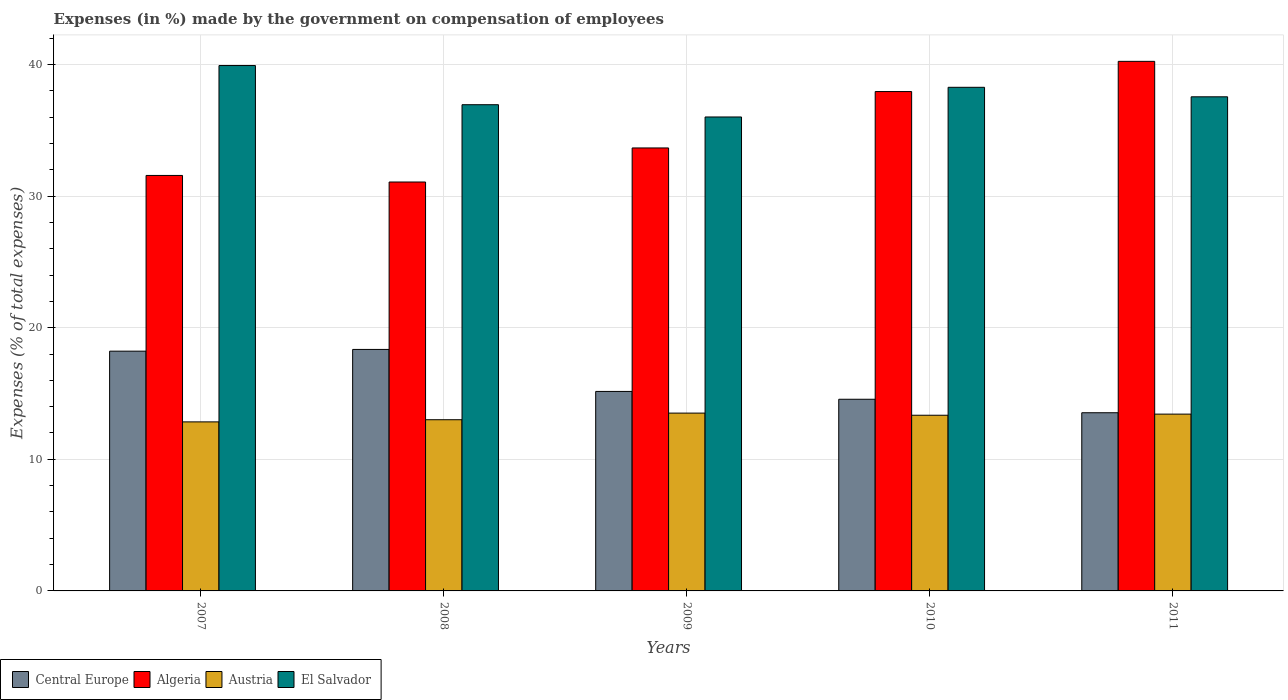How many different coloured bars are there?
Offer a very short reply. 4. How many groups of bars are there?
Provide a short and direct response. 5. Are the number of bars per tick equal to the number of legend labels?
Offer a terse response. Yes. Are the number of bars on each tick of the X-axis equal?
Your answer should be very brief. Yes. How many bars are there on the 1st tick from the left?
Make the answer very short. 4. How many bars are there on the 3rd tick from the right?
Offer a very short reply. 4. What is the label of the 4th group of bars from the left?
Provide a succinct answer. 2010. In how many cases, is the number of bars for a given year not equal to the number of legend labels?
Provide a short and direct response. 0. What is the percentage of expenses made by the government on compensation of employees in Central Europe in 2011?
Make the answer very short. 13.54. Across all years, what is the maximum percentage of expenses made by the government on compensation of employees in Algeria?
Make the answer very short. 40.23. Across all years, what is the minimum percentage of expenses made by the government on compensation of employees in El Salvador?
Keep it short and to the point. 36.01. What is the total percentage of expenses made by the government on compensation of employees in Austria in the graph?
Provide a succinct answer. 66.14. What is the difference between the percentage of expenses made by the government on compensation of employees in Algeria in 2007 and that in 2008?
Keep it short and to the point. 0.5. What is the difference between the percentage of expenses made by the government on compensation of employees in Algeria in 2008 and the percentage of expenses made by the government on compensation of employees in Austria in 2009?
Keep it short and to the point. 17.56. What is the average percentage of expenses made by the government on compensation of employees in Austria per year?
Offer a terse response. 13.23. In the year 2010, what is the difference between the percentage of expenses made by the government on compensation of employees in Austria and percentage of expenses made by the government on compensation of employees in El Salvador?
Make the answer very short. -24.92. In how many years, is the percentage of expenses made by the government on compensation of employees in Central Europe greater than 16 %?
Offer a very short reply. 2. What is the ratio of the percentage of expenses made by the government on compensation of employees in Central Europe in 2008 to that in 2009?
Provide a short and direct response. 1.21. Is the percentage of expenses made by the government on compensation of employees in Austria in 2007 less than that in 2009?
Offer a very short reply. Yes. What is the difference between the highest and the second highest percentage of expenses made by the government on compensation of employees in Central Europe?
Ensure brevity in your answer.  0.13. What is the difference between the highest and the lowest percentage of expenses made by the government on compensation of employees in Algeria?
Offer a very short reply. 9.17. In how many years, is the percentage of expenses made by the government on compensation of employees in El Salvador greater than the average percentage of expenses made by the government on compensation of employees in El Salvador taken over all years?
Offer a very short reply. 2. Is the sum of the percentage of expenses made by the government on compensation of employees in El Salvador in 2009 and 2010 greater than the maximum percentage of expenses made by the government on compensation of employees in Algeria across all years?
Give a very brief answer. Yes. Is it the case that in every year, the sum of the percentage of expenses made by the government on compensation of employees in Central Europe and percentage of expenses made by the government on compensation of employees in Austria is greater than the sum of percentage of expenses made by the government on compensation of employees in Algeria and percentage of expenses made by the government on compensation of employees in El Salvador?
Give a very brief answer. No. What does the 2nd bar from the left in 2008 represents?
Your answer should be compact. Algeria. What does the 4th bar from the right in 2011 represents?
Offer a terse response. Central Europe. How many bars are there?
Provide a short and direct response. 20. Are the values on the major ticks of Y-axis written in scientific E-notation?
Make the answer very short. No. Does the graph contain any zero values?
Your answer should be very brief. No. Where does the legend appear in the graph?
Provide a short and direct response. Bottom left. What is the title of the graph?
Your answer should be compact. Expenses (in %) made by the government on compensation of employees. Does "Bahrain" appear as one of the legend labels in the graph?
Your answer should be very brief. No. What is the label or title of the X-axis?
Provide a short and direct response. Years. What is the label or title of the Y-axis?
Your answer should be very brief. Expenses (% of total expenses). What is the Expenses (% of total expenses) in Central Europe in 2007?
Your response must be concise. 18.22. What is the Expenses (% of total expenses) in Algeria in 2007?
Your answer should be very brief. 31.57. What is the Expenses (% of total expenses) of Austria in 2007?
Offer a terse response. 12.84. What is the Expenses (% of total expenses) of El Salvador in 2007?
Give a very brief answer. 39.92. What is the Expenses (% of total expenses) in Central Europe in 2008?
Provide a succinct answer. 18.35. What is the Expenses (% of total expenses) of Algeria in 2008?
Your answer should be compact. 31.07. What is the Expenses (% of total expenses) of Austria in 2008?
Offer a terse response. 13.01. What is the Expenses (% of total expenses) of El Salvador in 2008?
Make the answer very short. 36.94. What is the Expenses (% of total expenses) in Central Europe in 2009?
Provide a short and direct response. 15.16. What is the Expenses (% of total expenses) of Algeria in 2009?
Offer a very short reply. 33.66. What is the Expenses (% of total expenses) in Austria in 2009?
Your response must be concise. 13.51. What is the Expenses (% of total expenses) in El Salvador in 2009?
Your answer should be very brief. 36.01. What is the Expenses (% of total expenses) of Central Europe in 2010?
Provide a succinct answer. 14.56. What is the Expenses (% of total expenses) in Algeria in 2010?
Ensure brevity in your answer.  37.94. What is the Expenses (% of total expenses) in Austria in 2010?
Offer a terse response. 13.35. What is the Expenses (% of total expenses) of El Salvador in 2010?
Your answer should be compact. 38.26. What is the Expenses (% of total expenses) of Central Europe in 2011?
Your answer should be compact. 13.54. What is the Expenses (% of total expenses) in Algeria in 2011?
Provide a succinct answer. 40.23. What is the Expenses (% of total expenses) in Austria in 2011?
Offer a very short reply. 13.43. What is the Expenses (% of total expenses) in El Salvador in 2011?
Make the answer very short. 37.54. Across all years, what is the maximum Expenses (% of total expenses) of Central Europe?
Your answer should be very brief. 18.35. Across all years, what is the maximum Expenses (% of total expenses) in Algeria?
Your response must be concise. 40.23. Across all years, what is the maximum Expenses (% of total expenses) of Austria?
Your answer should be compact. 13.51. Across all years, what is the maximum Expenses (% of total expenses) in El Salvador?
Your answer should be very brief. 39.92. Across all years, what is the minimum Expenses (% of total expenses) in Central Europe?
Keep it short and to the point. 13.54. Across all years, what is the minimum Expenses (% of total expenses) in Algeria?
Give a very brief answer. 31.07. Across all years, what is the minimum Expenses (% of total expenses) in Austria?
Make the answer very short. 12.84. Across all years, what is the minimum Expenses (% of total expenses) in El Salvador?
Your response must be concise. 36.01. What is the total Expenses (% of total expenses) in Central Europe in the graph?
Provide a short and direct response. 79.82. What is the total Expenses (% of total expenses) in Algeria in the graph?
Give a very brief answer. 174.46. What is the total Expenses (% of total expenses) of Austria in the graph?
Offer a terse response. 66.14. What is the total Expenses (% of total expenses) of El Salvador in the graph?
Offer a very short reply. 188.67. What is the difference between the Expenses (% of total expenses) of Central Europe in 2007 and that in 2008?
Keep it short and to the point. -0.13. What is the difference between the Expenses (% of total expenses) in Algeria in 2007 and that in 2008?
Give a very brief answer. 0.5. What is the difference between the Expenses (% of total expenses) of Austria in 2007 and that in 2008?
Your response must be concise. -0.16. What is the difference between the Expenses (% of total expenses) of El Salvador in 2007 and that in 2008?
Provide a short and direct response. 2.98. What is the difference between the Expenses (% of total expenses) in Central Europe in 2007 and that in 2009?
Your answer should be very brief. 3.06. What is the difference between the Expenses (% of total expenses) in Algeria in 2007 and that in 2009?
Provide a succinct answer. -2.09. What is the difference between the Expenses (% of total expenses) in Austria in 2007 and that in 2009?
Ensure brevity in your answer.  -0.67. What is the difference between the Expenses (% of total expenses) of El Salvador in 2007 and that in 2009?
Give a very brief answer. 3.91. What is the difference between the Expenses (% of total expenses) of Central Europe in 2007 and that in 2010?
Provide a short and direct response. 3.65. What is the difference between the Expenses (% of total expenses) of Algeria in 2007 and that in 2010?
Provide a short and direct response. -6.37. What is the difference between the Expenses (% of total expenses) in Austria in 2007 and that in 2010?
Offer a terse response. -0.5. What is the difference between the Expenses (% of total expenses) of El Salvador in 2007 and that in 2010?
Your answer should be compact. 1.65. What is the difference between the Expenses (% of total expenses) of Central Europe in 2007 and that in 2011?
Your response must be concise. 4.68. What is the difference between the Expenses (% of total expenses) of Algeria in 2007 and that in 2011?
Your answer should be compact. -8.67. What is the difference between the Expenses (% of total expenses) in Austria in 2007 and that in 2011?
Keep it short and to the point. -0.59. What is the difference between the Expenses (% of total expenses) of El Salvador in 2007 and that in 2011?
Make the answer very short. 2.37. What is the difference between the Expenses (% of total expenses) in Central Europe in 2008 and that in 2009?
Give a very brief answer. 3.19. What is the difference between the Expenses (% of total expenses) in Algeria in 2008 and that in 2009?
Provide a short and direct response. -2.59. What is the difference between the Expenses (% of total expenses) in Austria in 2008 and that in 2009?
Make the answer very short. -0.5. What is the difference between the Expenses (% of total expenses) of El Salvador in 2008 and that in 2009?
Your response must be concise. 0.93. What is the difference between the Expenses (% of total expenses) in Central Europe in 2008 and that in 2010?
Offer a terse response. 3.79. What is the difference between the Expenses (% of total expenses) in Algeria in 2008 and that in 2010?
Your response must be concise. -6.87. What is the difference between the Expenses (% of total expenses) in Austria in 2008 and that in 2010?
Give a very brief answer. -0.34. What is the difference between the Expenses (% of total expenses) of El Salvador in 2008 and that in 2010?
Your answer should be compact. -1.32. What is the difference between the Expenses (% of total expenses) in Central Europe in 2008 and that in 2011?
Your answer should be compact. 4.81. What is the difference between the Expenses (% of total expenses) of Algeria in 2008 and that in 2011?
Provide a short and direct response. -9.17. What is the difference between the Expenses (% of total expenses) in Austria in 2008 and that in 2011?
Ensure brevity in your answer.  -0.43. What is the difference between the Expenses (% of total expenses) in El Salvador in 2008 and that in 2011?
Make the answer very short. -0.6. What is the difference between the Expenses (% of total expenses) of Central Europe in 2009 and that in 2010?
Make the answer very short. 0.59. What is the difference between the Expenses (% of total expenses) in Algeria in 2009 and that in 2010?
Provide a short and direct response. -4.28. What is the difference between the Expenses (% of total expenses) of Austria in 2009 and that in 2010?
Ensure brevity in your answer.  0.16. What is the difference between the Expenses (% of total expenses) in El Salvador in 2009 and that in 2010?
Make the answer very short. -2.25. What is the difference between the Expenses (% of total expenses) of Central Europe in 2009 and that in 2011?
Your answer should be very brief. 1.62. What is the difference between the Expenses (% of total expenses) in Algeria in 2009 and that in 2011?
Your response must be concise. -6.58. What is the difference between the Expenses (% of total expenses) of Austria in 2009 and that in 2011?
Your answer should be very brief. 0.08. What is the difference between the Expenses (% of total expenses) of El Salvador in 2009 and that in 2011?
Your response must be concise. -1.53. What is the difference between the Expenses (% of total expenses) in Central Europe in 2010 and that in 2011?
Your response must be concise. 1.02. What is the difference between the Expenses (% of total expenses) in Algeria in 2010 and that in 2011?
Your answer should be very brief. -2.29. What is the difference between the Expenses (% of total expenses) in Austria in 2010 and that in 2011?
Make the answer very short. -0.09. What is the difference between the Expenses (% of total expenses) in El Salvador in 2010 and that in 2011?
Your response must be concise. 0.72. What is the difference between the Expenses (% of total expenses) of Central Europe in 2007 and the Expenses (% of total expenses) of Algeria in 2008?
Your answer should be compact. -12.85. What is the difference between the Expenses (% of total expenses) of Central Europe in 2007 and the Expenses (% of total expenses) of Austria in 2008?
Offer a terse response. 5.21. What is the difference between the Expenses (% of total expenses) in Central Europe in 2007 and the Expenses (% of total expenses) in El Salvador in 2008?
Your answer should be compact. -18.72. What is the difference between the Expenses (% of total expenses) of Algeria in 2007 and the Expenses (% of total expenses) of Austria in 2008?
Your response must be concise. 18.56. What is the difference between the Expenses (% of total expenses) of Algeria in 2007 and the Expenses (% of total expenses) of El Salvador in 2008?
Provide a short and direct response. -5.37. What is the difference between the Expenses (% of total expenses) of Austria in 2007 and the Expenses (% of total expenses) of El Salvador in 2008?
Your response must be concise. -24.1. What is the difference between the Expenses (% of total expenses) of Central Europe in 2007 and the Expenses (% of total expenses) of Algeria in 2009?
Keep it short and to the point. -15.44. What is the difference between the Expenses (% of total expenses) in Central Europe in 2007 and the Expenses (% of total expenses) in Austria in 2009?
Provide a succinct answer. 4.71. What is the difference between the Expenses (% of total expenses) of Central Europe in 2007 and the Expenses (% of total expenses) of El Salvador in 2009?
Make the answer very short. -17.79. What is the difference between the Expenses (% of total expenses) in Algeria in 2007 and the Expenses (% of total expenses) in Austria in 2009?
Your answer should be very brief. 18.06. What is the difference between the Expenses (% of total expenses) in Algeria in 2007 and the Expenses (% of total expenses) in El Salvador in 2009?
Provide a succinct answer. -4.44. What is the difference between the Expenses (% of total expenses) of Austria in 2007 and the Expenses (% of total expenses) of El Salvador in 2009?
Your answer should be very brief. -23.17. What is the difference between the Expenses (% of total expenses) of Central Europe in 2007 and the Expenses (% of total expenses) of Algeria in 2010?
Provide a succinct answer. -19.72. What is the difference between the Expenses (% of total expenses) in Central Europe in 2007 and the Expenses (% of total expenses) in Austria in 2010?
Make the answer very short. 4.87. What is the difference between the Expenses (% of total expenses) in Central Europe in 2007 and the Expenses (% of total expenses) in El Salvador in 2010?
Provide a succinct answer. -20.05. What is the difference between the Expenses (% of total expenses) of Algeria in 2007 and the Expenses (% of total expenses) of Austria in 2010?
Your response must be concise. 18.22. What is the difference between the Expenses (% of total expenses) of Algeria in 2007 and the Expenses (% of total expenses) of El Salvador in 2010?
Your answer should be compact. -6.7. What is the difference between the Expenses (% of total expenses) in Austria in 2007 and the Expenses (% of total expenses) in El Salvador in 2010?
Your response must be concise. -25.42. What is the difference between the Expenses (% of total expenses) in Central Europe in 2007 and the Expenses (% of total expenses) in Algeria in 2011?
Keep it short and to the point. -22.02. What is the difference between the Expenses (% of total expenses) in Central Europe in 2007 and the Expenses (% of total expenses) in Austria in 2011?
Your answer should be very brief. 4.78. What is the difference between the Expenses (% of total expenses) of Central Europe in 2007 and the Expenses (% of total expenses) of El Salvador in 2011?
Your answer should be compact. -19.33. What is the difference between the Expenses (% of total expenses) of Algeria in 2007 and the Expenses (% of total expenses) of Austria in 2011?
Give a very brief answer. 18.13. What is the difference between the Expenses (% of total expenses) in Algeria in 2007 and the Expenses (% of total expenses) in El Salvador in 2011?
Your answer should be compact. -5.97. What is the difference between the Expenses (% of total expenses) in Austria in 2007 and the Expenses (% of total expenses) in El Salvador in 2011?
Offer a terse response. -24.7. What is the difference between the Expenses (% of total expenses) in Central Europe in 2008 and the Expenses (% of total expenses) in Algeria in 2009?
Give a very brief answer. -15.31. What is the difference between the Expenses (% of total expenses) of Central Europe in 2008 and the Expenses (% of total expenses) of Austria in 2009?
Your answer should be compact. 4.84. What is the difference between the Expenses (% of total expenses) in Central Europe in 2008 and the Expenses (% of total expenses) in El Salvador in 2009?
Provide a succinct answer. -17.66. What is the difference between the Expenses (% of total expenses) in Algeria in 2008 and the Expenses (% of total expenses) in Austria in 2009?
Provide a succinct answer. 17.56. What is the difference between the Expenses (% of total expenses) of Algeria in 2008 and the Expenses (% of total expenses) of El Salvador in 2009?
Offer a very short reply. -4.94. What is the difference between the Expenses (% of total expenses) of Austria in 2008 and the Expenses (% of total expenses) of El Salvador in 2009?
Offer a terse response. -23. What is the difference between the Expenses (% of total expenses) in Central Europe in 2008 and the Expenses (% of total expenses) in Algeria in 2010?
Provide a short and direct response. -19.59. What is the difference between the Expenses (% of total expenses) in Central Europe in 2008 and the Expenses (% of total expenses) in Austria in 2010?
Your response must be concise. 5. What is the difference between the Expenses (% of total expenses) of Central Europe in 2008 and the Expenses (% of total expenses) of El Salvador in 2010?
Your answer should be very brief. -19.92. What is the difference between the Expenses (% of total expenses) of Algeria in 2008 and the Expenses (% of total expenses) of Austria in 2010?
Your response must be concise. 17.72. What is the difference between the Expenses (% of total expenses) of Algeria in 2008 and the Expenses (% of total expenses) of El Salvador in 2010?
Ensure brevity in your answer.  -7.2. What is the difference between the Expenses (% of total expenses) in Austria in 2008 and the Expenses (% of total expenses) in El Salvador in 2010?
Make the answer very short. -25.26. What is the difference between the Expenses (% of total expenses) of Central Europe in 2008 and the Expenses (% of total expenses) of Algeria in 2011?
Make the answer very short. -21.89. What is the difference between the Expenses (% of total expenses) in Central Europe in 2008 and the Expenses (% of total expenses) in Austria in 2011?
Give a very brief answer. 4.92. What is the difference between the Expenses (% of total expenses) of Central Europe in 2008 and the Expenses (% of total expenses) of El Salvador in 2011?
Offer a terse response. -19.19. What is the difference between the Expenses (% of total expenses) of Algeria in 2008 and the Expenses (% of total expenses) of Austria in 2011?
Your answer should be very brief. 17.63. What is the difference between the Expenses (% of total expenses) in Algeria in 2008 and the Expenses (% of total expenses) in El Salvador in 2011?
Your answer should be compact. -6.47. What is the difference between the Expenses (% of total expenses) in Austria in 2008 and the Expenses (% of total expenses) in El Salvador in 2011?
Offer a very short reply. -24.53. What is the difference between the Expenses (% of total expenses) in Central Europe in 2009 and the Expenses (% of total expenses) in Algeria in 2010?
Keep it short and to the point. -22.78. What is the difference between the Expenses (% of total expenses) of Central Europe in 2009 and the Expenses (% of total expenses) of Austria in 2010?
Make the answer very short. 1.81. What is the difference between the Expenses (% of total expenses) of Central Europe in 2009 and the Expenses (% of total expenses) of El Salvador in 2010?
Your answer should be very brief. -23.11. What is the difference between the Expenses (% of total expenses) in Algeria in 2009 and the Expenses (% of total expenses) in Austria in 2010?
Your answer should be very brief. 20.31. What is the difference between the Expenses (% of total expenses) of Algeria in 2009 and the Expenses (% of total expenses) of El Salvador in 2010?
Offer a very short reply. -4.61. What is the difference between the Expenses (% of total expenses) of Austria in 2009 and the Expenses (% of total expenses) of El Salvador in 2010?
Give a very brief answer. -24.75. What is the difference between the Expenses (% of total expenses) in Central Europe in 2009 and the Expenses (% of total expenses) in Algeria in 2011?
Make the answer very short. -25.08. What is the difference between the Expenses (% of total expenses) in Central Europe in 2009 and the Expenses (% of total expenses) in Austria in 2011?
Your answer should be compact. 1.72. What is the difference between the Expenses (% of total expenses) in Central Europe in 2009 and the Expenses (% of total expenses) in El Salvador in 2011?
Your answer should be compact. -22.39. What is the difference between the Expenses (% of total expenses) in Algeria in 2009 and the Expenses (% of total expenses) in Austria in 2011?
Offer a terse response. 20.22. What is the difference between the Expenses (% of total expenses) in Algeria in 2009 and the Expenses (% of total expenses) in El Salvador in 2011?
Your answer should be compact. -3.89. What is the difference between the Expenses (% of total expenses) in Austria in 2009 and the Expenses (% of total expenses) in El Salvador in 2011?
Give a very brief answer. -24.03. What is the difference between the Expenses (% of total expenses) in Central Europe in 2010 and the Expenses (% of total expenses) in Algeria in 2011?
Make the answer very short. -25.67. What is the difference between the Expenses (% of total expenses) in Central Europe in 2010 and the Expenses (% of total expenses) in Austria in 2011?
Provide a short and direct response. 1.13. What is the difference between the Expenses (% of total expenses) in Central Europe in 2010 and the Expenses (% of total expenses) in El Salvador in 2011?
Keep it short and to the point. -22.98. What is the difference between the Expenses (% of total expenses) in Algeria in 2010 and the Expenses (% of total expenses) in Austria in 2011?
Make the answer very short. 24.51. What is the difference between the Expenses (% of total expenses) of Algeria in 2010 and the Expenses (% of total expenses) of El Salvador in 2011?
Offer a terse response. 0.4. What is the difference between the Expenses (% of total expenses) in Austria in 2010 and the Expenses (% of total expenses) in El Salvador in 2011?
Provide a short and direct response. -24.19. What is the average Expenses (% of total expenses) in Central Europe per year?
Give a very brief answer. 15.96. What is the average Expenses (% of total expenses) of Algeria per year?
Your response must be concise. 34.89. What is the average Expenses (% of total expenses) in Austria per year?
Offer a very short reply. 13.23. What is the average Expenses (% of total expenses) of El Salvador per year?
Your response must be concise. 37.73. In the year 2007, what is the difference between the Expenses (% of total expenses) in Central Europe and Expenses (% of total expenses) in Algeria?
Your answer should be compact. -13.35. In the year 2007, what is the difference between the Expenses (% of total expenses) in Central Europe and Expenses (% of total expenses) in Austria?
Make the answer very short. 5.37. In the year 2007, what is the difference between the Expenses (% of total expenses) in Central Europe and Expenses (% of total expenses) in El Salvador?
Your answer should be very brief. -21.7. In the year 2007, what is the difference between the Expenses (% of total expenses) in Algeria and Expenses (% of total expenses) in Austria?
Give a very brief answer. 18.72. In the year 2007, what is the difference between the Expenses (% of total expenses) of Algeria and Expenses (% of total expenses) of El Salvador?
Offer a terse response. -8.35. In the year 2007, what is the difference between the Expenses (% of total expenses) in Austria and Expenses (% of total expenses) in El Salvador?
Offer a very short reply. -27.07. In the year 2008, what is the difference between the Expenses (% of total expenses) in Central Europe and Expenses (% of total expenses) in Algeria?
Provide a short and direct response. -12.72. In the year 2008, what is the difference between the Expenses (% of total expenses) of Central Europe and Expenses (% of total expenses) of Austria?
Give a very brief answer. 5.34. In the year 2008, what is the difference between the Expenses (% of total expenses) of Central Europe and Expenses (% of total expenses) of El Salvador?
Provide a succinct answer. -18.59. In the year 2008, what is the difference between the Expenses (% of total expenses) of Algeria and Expenses (% of total expenses) of Austria?
Your answer should be compact. 18.06. In the year 2008, what is the difference between the Expenses (% of total expenses) in Algeria and Expenses (% of total expenses) in El Salvador?
Give a very brief answer. -5.87. In the year 2008, what is the difference between the Expenses (% of total expenses) in Austria and Expenses (% of total expenses) in El Salvador?
Provide a short and direct response. -23.93. In the year 2009, what is the difference between the Expenses (% of total expenses) in Central Europe and Expenses (% of total expenses) in Algeria?
Your answer should be compact. -18.5. In the year 2009, what is the difference between the Expenses (% of total expenses) of Central Europe and Expenses (% of total expenses) of Austria?
Your response must be concise. 1.65. In the year 2009, what is the difference between the Expenses (% of total expenses) in Central Europe and Expenses (% of total expenses) in El Salvador?
Offer a very short reply. -20.85. In the year 2009, what is the difference between the Expenses (% of total expenses) of Algeria and Expenses (% of total expenses) of Austria?
Offer a very short reply. 20.14. In the year 2009, what is the difference between the Expenses (% of total expenses) of Algeria and Expenses (% of total expenses) of El Salvador?
Ensure brevity in your answer.  -2.35. In the year 2009, what is the difference between the Expenses (% of total expenses) of Austria and Expenses (% of total expenses) of El Salvador?
Ensure brevity in your answer.  -22.5. In the year 2010, what is the difference between the Expenses (% of total expenses) in Central Europe and Expenses (% of total expenses) in Algeria?
Keep it short and to the point. -23.38. In the year 2010, what is the difference between the Expenses (% of total expenses) of Central Europe and Expenses (% of total expenses) of Austria?
Keep it short and to the point. 1.21. In the year 2010, what is the difference between the Expenses (% of total expenses) of Central Europe and Expenses (% of total expenses) of El Salvador?
Your answer should be very brief. -23.7. In the year 2010, what is the difference between the Expenses (% of total expenses) in Algeria and Expenses (% of total expenses) in Austria?
Offer a terse response. 24.59. In the year 2010, what is the difference between the Expenses (% of total expenses) of Algeria and Expenses (% of total expenses) of El Salvador?
Keep it short and to the point. -0.32. In the year 2010, what is the difference between the Expenses (% of total expenses) in Austria and Expenses (% of total expenses) in El Salvador?
Give a very brief answer. -24.92. In the year 2011, what is the difference between the Expenses (% of total expenses) of Central Europe and Expenses (% of total expenses) of Algeria?
Ensure brevity in your answer.  -26.7. In the year 2011, what is the difference between the Expenses (% of total expenses) of Central Europe and Expenses (% of total expenses) of Austria?
Your answer should be very brief. 0.11. In the year 2011, what is the difference between the Expenses (% of total expenses) of Central Europe and Expenses (% of total expenses) of El Salvador?
Provide a short and direct response. -24. In the year 2011, what is the difference between the Expenses (% of total expenses) of Algeria and Expenses (% of total expenses) of Austria?
Keep it short and to the point. 26.8. In the year 2011, what is the difference between the Expenses (% of total expenses) of Algeria and Expenses (% of total expenses) of El Salvador?
Your response must be concise. 2.69. In the year 2011, what is the difference between the Expenses (% of total expenses) in Austria and Expenses (% of total expenses) in El Salvador?
Your response must be concise. -24.11. What is the ratio of the Expenses (% of total expenses) in Central Europe in 2007 to that in 2008?
Offer a very short reply. 0.99. What is the ratio of the Expenses (% of total expenses) of Algeria in 2007 to that in 2008?
Offer a terse response. 1.02. What is the ratio of the Expenses (% of total expenses) in Austria in 2007 to that in 2008?
Your answer should be compact. 0.99. What is the ratio of the Expenses (% of total expenses) in El Salvador in 2007 to that in 2008?
Provide a short and direct response. 1.08. What is the ratio of the Expenses (% of total expenses) of Central Europe in 2007 to that in 2009?
Your answer should be compact. 1.2. What is the ratio of the Expenses (% of total expenses) of Algeria in 2007 to that in 2009?
Offer a very short reply. 0.94. What is the ratio of the Expenses (% of total expenses) of Austria in 2007 to that in 2009?
Offer a terse response. 0.95. What is the ratio of the Expenses (% of total expenses) of El Salvador in 2007 to that in 2009?
Your answer should be very brief. 1.11. What is the ratio of the Expenses (% of total expenses) in Central Europe in 2007 to that in 2010?
Offer a very short reply. 1.25. What is the ratio of the Expenses (% of total expenses) in Algeria in 2007 to that in 2010?
Your answer should be very brief. 0.83. What is the ratio of the Expenses (% of total expenses) of Austria in 2007 to that in 2010?
Provide a short and direct response. 0.96. What is the ratio of the Expenses (% of total expenses) of El Salvador in 2007 to that in 2010?
Provide a short and direct response. 1.04. What is the ratio of the Expenses (% of total expenses) in Central Europe in 2007 to that in 2011?
Your answer should be compact. 1.35. What is the ratio of the Expenses (% of total expenses) of Algeria in 2007 to that in 2011?
Make the answer very short. 0.78. What is the ratio of the Expenses (% of total expenses) in Austria in 2007 to that in 2011?
Provide a succinct answer. 0.96. What is the ratio of the Expenses (% of total expenses) in El Salvador in 2007 to that in 2011?
Your response must be concise. 1.06. What is the ratio of the Expenses (% of total expenses) in Central Europe in 2008 to that in 2009?
Provide a succinct answer. 1.21. What is the ratio of the Expenses (% of total expenses) of Algeria in 2008 to that in 2009?
Make the answer very short. 0.92. What is the ratio of the Expenses (% of total expenses) in Austria in 2008 to that in 2009?
Keep it short and to the point. 0.96. What is the ratio of the Expenses (% of total expenses) in El Salvador in 2008 to that in 2009?
Make the answer very short. 1.03. What is the ratio of the Expenses (% of total expenses) in Central Europe in 2008 to that in 2010?
Your answer should be compact. 1.26. What is the ratio of the Expenses (% of total expenses) of Algeria in 2008 to that in 2010?
Your answer should be very brief. 0.82. What is the ratio of the Expenses (% of total expenses) in Austria in 2008 to that in 2010?
Ensure brevity in your answer.  0.97. What is the ratio of the Expenses (% of total expenses) in El Salvador in 2008 to that in 2010?
Make the answer very short. 0.97. What is the ratio of the Expenses (% of total expenses) in Central Europe in 2008 to that in 2011?
Offer a terse response. 1.36. What is the ratio of the Expenses (% of total expenses) of Algeria in 2008 to that in 2011?
Ensure brevity in your answer.  0.77. What is the ratio of the Expenses (% of total expenses) in Austria in 2008 to that in 2011?
Keep it short and to the point. 0.97. What is the ratio of the Expenses (% of total expenses) in El Salvador in 2008 to that in 2011?
Keep it short and to the point. 0.98. What is the ratio of the Expenses (% of total expenses) of Central Europe in 2009 to that in 2010?
Make the answer very short. 1.04. What is the ratio of the Expenses (% of total expenses) in Algeria in 2009 to that in 2010?
Your response must be concise. 0.89. What is the ratio of the Expenses (% of total expenses) in Austria in 2009 to that in 2010?
Your answer should be very brief. 1.01. What is the ratio of the Expenses (% of total expenses) in El Salvador in 2009 to that in 2010?
Keep it short and to the point. 0.94. What is the ratio of the Expenses (% of total expenses) of Central Europe in 2009 to that in 2011?
Your response must be concise. 1.12. What is the ratio of the Expenses (% of total expenses) in Algeria in 2009 to that in 2011?
Provide a succinct answer. 0.84. What is the ratio of the Expenses (% of total expenses) in Austria in 2009 to that in 2011?
Your answer should be compact. 1.01. What is the ratio of the Expenses (% of total expenses) of El Salvador in 2009 to that in 2011?
Offer a very short reply. 0.96. What is the ratio of the Expenses (% of total expenses) in Central Europe in 2010 to that in 2011?
Make the answer very short. 1.08. What is the ratio of the Expenses (% of total expenses) of Algeria in 2010 to that in 2011?
Offer a terse response. 0.94. What is the ratio of the Expenses (% of total expenses) of El Salvador in 2010 to that in 2011?
Keep it short and to the point. 1.02. What is the difference between the highest and the second highest Expenses (% of total expenses) in Central Europe?
Provide a short and direct response. 0.13. What is the difference between the highest and the second highest Expenses (% of total expenses) of Algeria?
Keep it short and to the point. 2.29. What is the difference between the highest and the second highest Expenses (% of total expenses) in Austria?
Offer a very short reply. 0.08. What is the difference between the highest and the second highest Expenses (% of total expenses) of El Salvador?
Offer a terse response. 1.65. What is the difference between the highest and the lowest Expenses (% of total expenses) of Central Europe?
Provide a succinct answer. 4.81. What is the difference between the highest and the lowest Expenses (% of total expenses) of Algeria?
Give a very brief answer. 9.17. What is the difference between the highest and the lowest Expenses (% of total expenses) of Austria?
Give a very brief answer. 0.67. What is the difference between the highest and the lowest Expenses (% of total expenses) in El Salvador?
Provide a succinct answer. 3.91. 